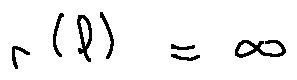Convert formula to latex. <formula><loc_0><loc_0><loc_500><loc_500>r ( l ) = \infty</formula> 